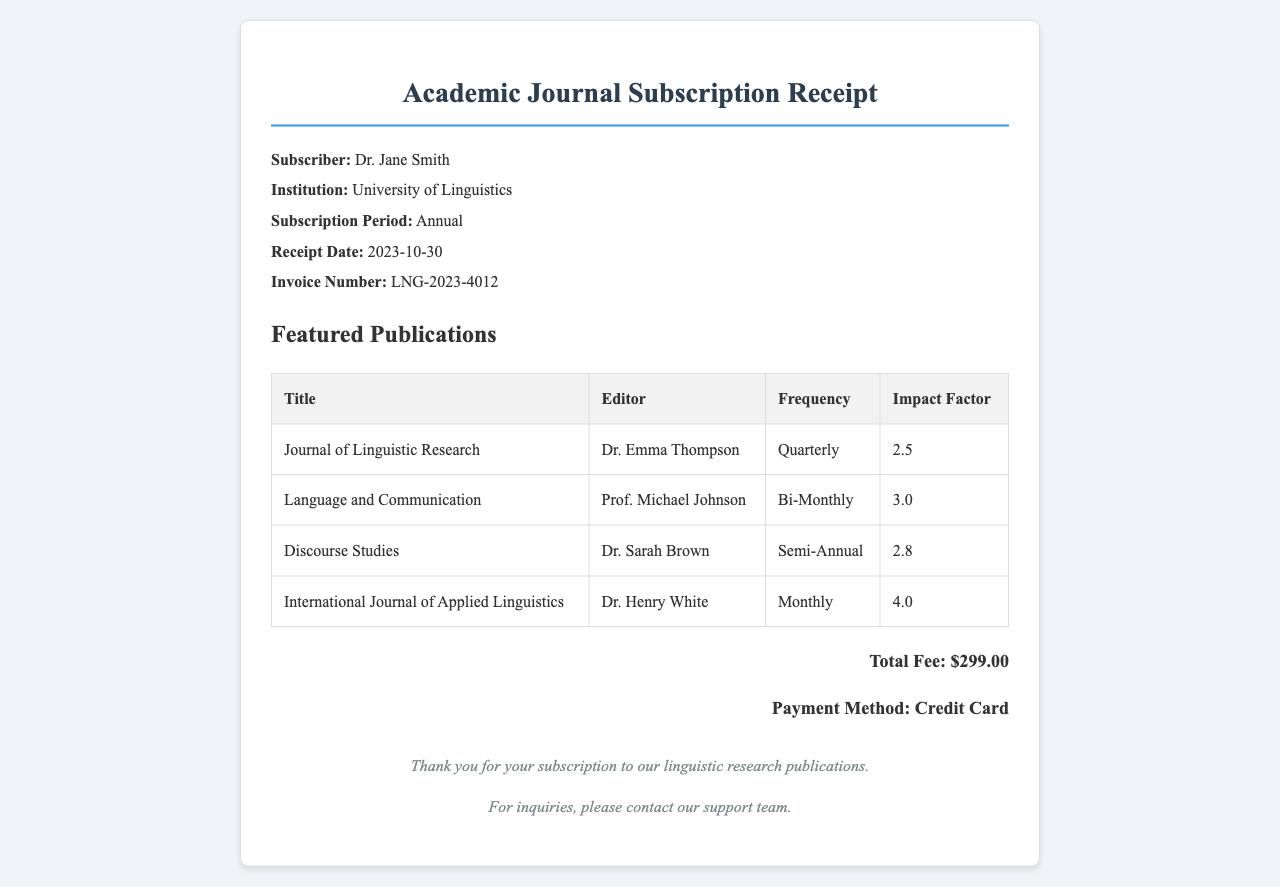What is the name of the subscriber? The name of the subscriber is provided in the receipt details section.
Answer: Dr. Jane Smith What is the institution associated with the subscriber? The institution is mentioned alongside the subscriber's name in the receipt details.
Answer: University of Linguistics What is the total fee listed on the receipt? The total fee is specified in the total section of the document.
Answer: $299.00 What is the frequency of the Journal of Linguistic Research? The frequency can be found in the featured publications table under the relevant title.
Answer: Quarterly Who is the editor of Language and Communication? The editor's name is listed in the featured publications section next to the title.
Answer: Prof. Michael Johnson What is the impact factor of the International Journal of Applied Linguistics? The impact factor is indicated in the featured publications table for this specific journal.
Answer: 4.0 What payment method was used for the subscription? The payment method is clearly stated in the total section of the receipt.
Answer: Credit Card What is the receipt date? The receipt date is provided in the details section of the document.
Answer: 2023-10-30 